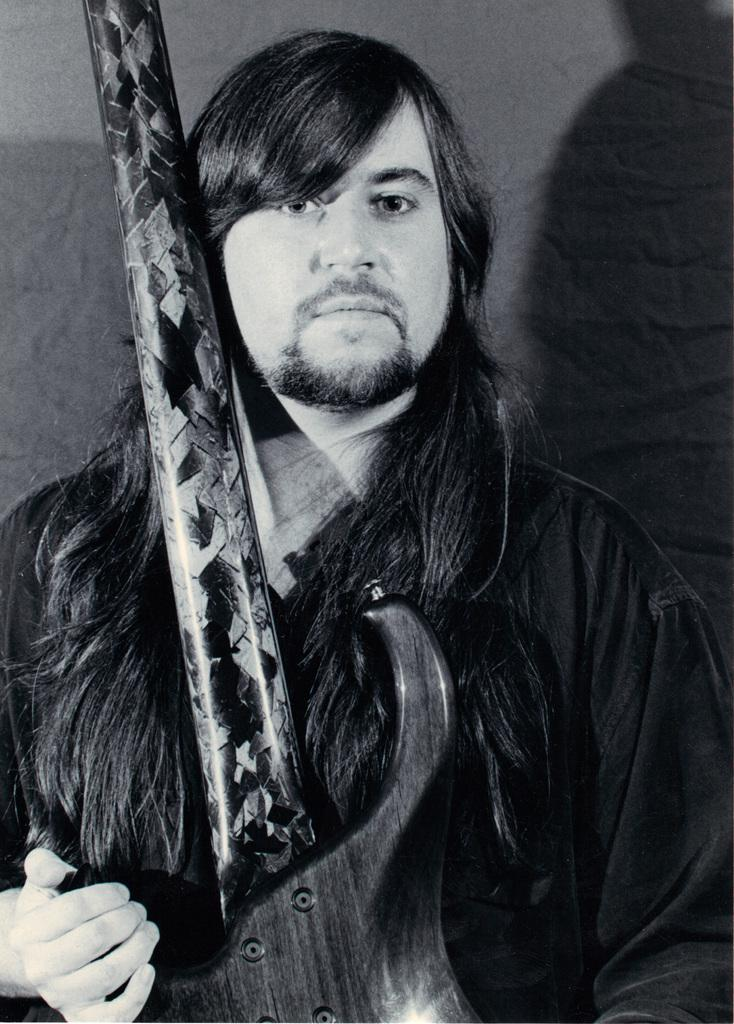Who is present in the image? There is a man in the image. What is the man holding in the image? The man is holding a guitar. What can be seen in the background of the image? A: There appears to be a wall in the background of the image. How many chairs are visible in the image? There are no chairs visible in the image. What type of pancake is the man eating in the image? There is no pancake present in the image; the man is holding a guitar. 